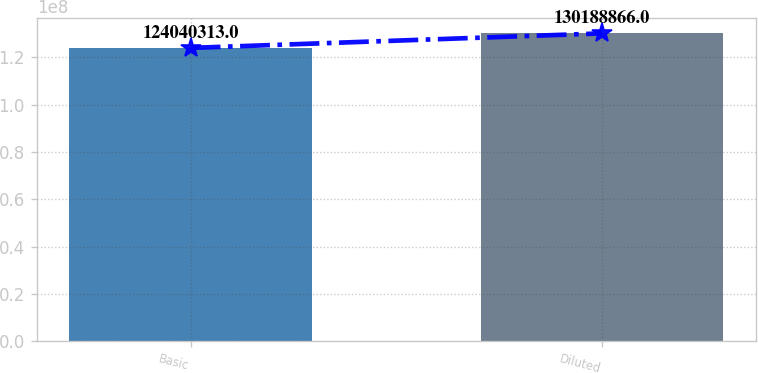<chart> <loc_0><loc_0><loc_500><loc_500><bar_chart><fcel>Basic<fcel>Diluted<nl><fcel>1.2404e+08<fcel>1.30189e+08<nl></chart> 